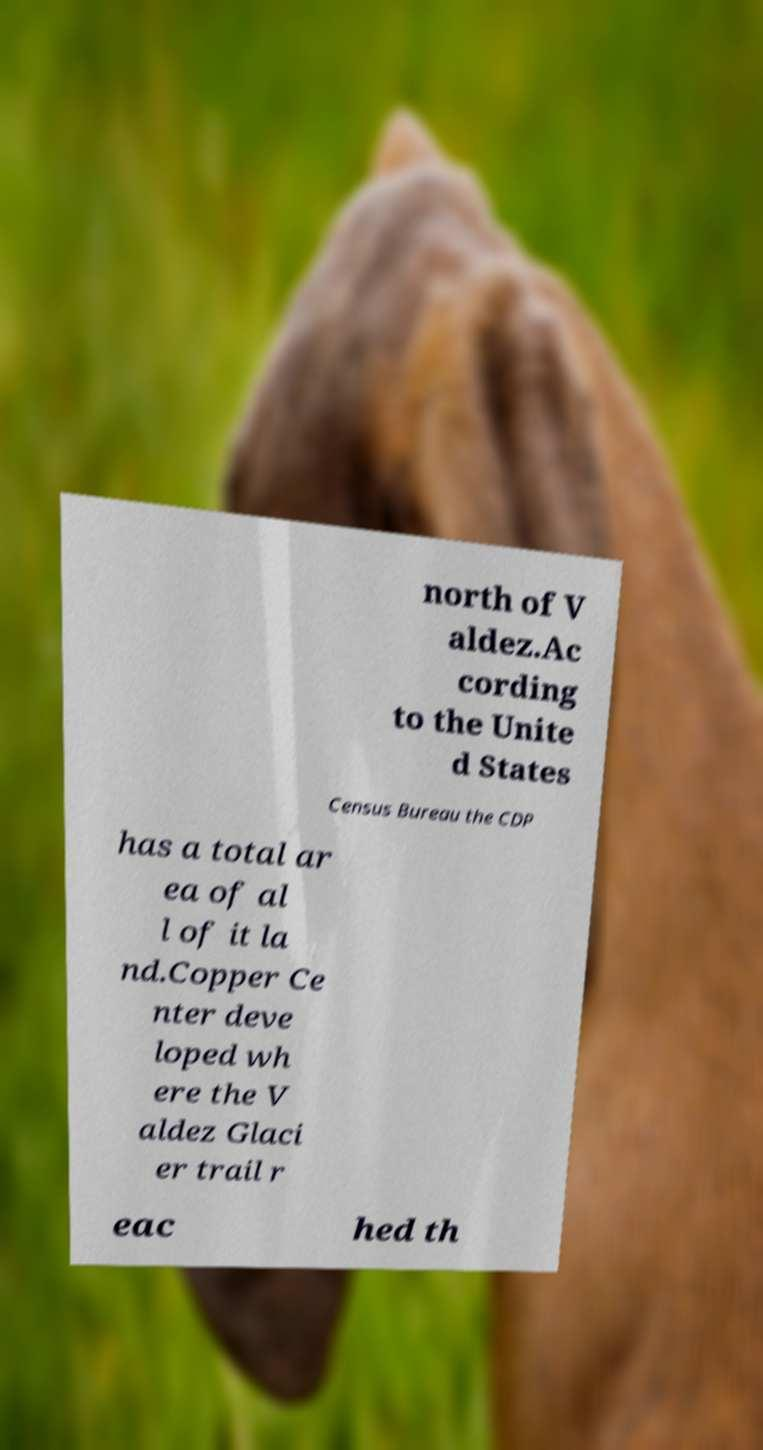I need the written content from this picture converted into text. Can you do that? north of V aldez.Ac cording to the Unite d States Census Bureau the CDP has a total ar ea of al l of it la nd.Copper Ce nter deve loped wh ere the V aldez Glaci er trail r eac hed th 